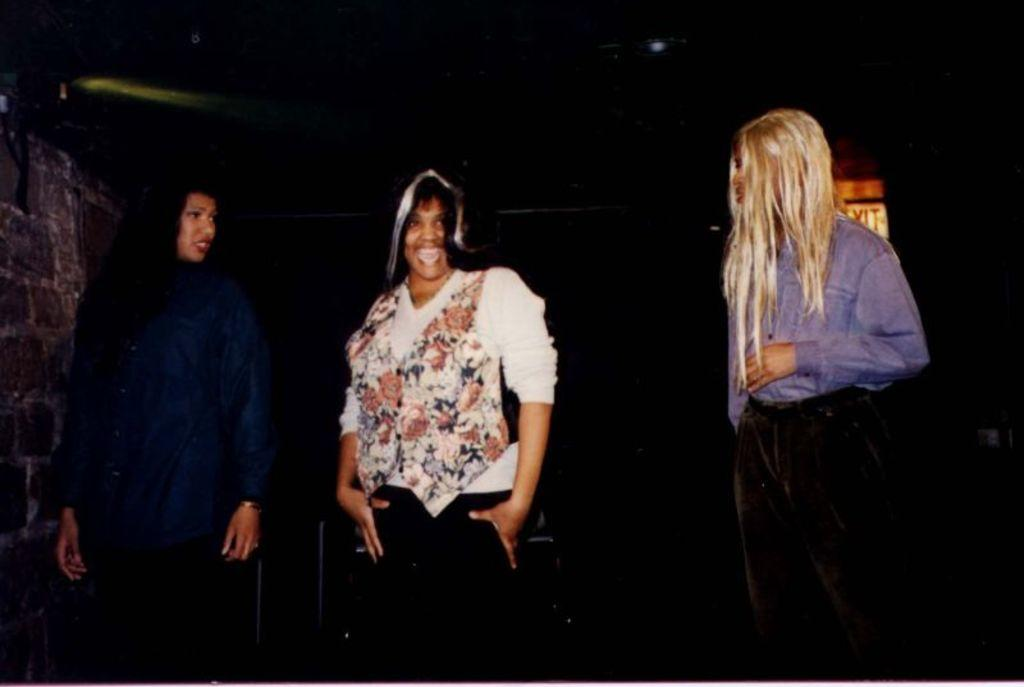How many women are present in the image? There are three women in the image. Can you describe the clothing of one of the women? One woman is wearing a blue shirt. What color shirt is the other woman wearing? The other woman is wearing a white shirt. What type of crate is being used by the women in the image? There is no crate present in the image. What achievements have the women accomplished, as seen in the image? The image does not provide information about the women's achievements. 